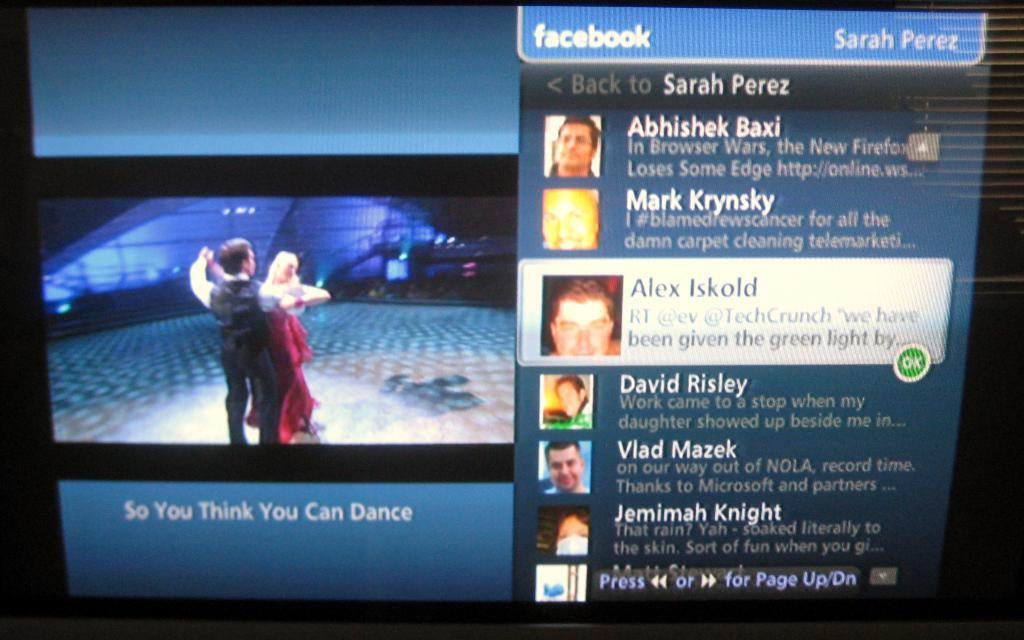Provide a one-sentence caption for the provided image. some names on a screen with Alex Iskold on it. 